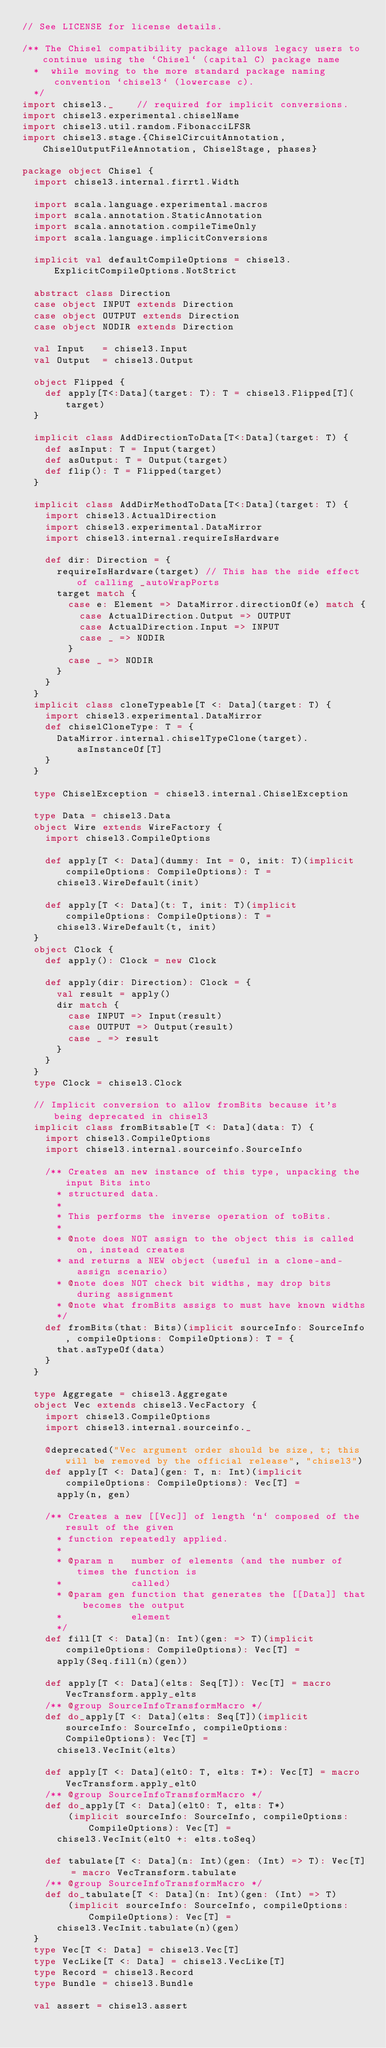<code> <loc_0><loc_0><loc_500><loc_500><_Scala_>// See LICENSE for license details.

/** The Chisel compatibility package allows legacy users to continue using the `Chisel` (capital C) package name
  *  while moving to the more standard package naming convention `chisel3` (lowercase c).
  */
import chisel3._    // required for implicit conversions.
import chisel3.experimental.chiselName
import chisel3.util.random.FibonacciLFSR
import chisel3.stage.{ChiselCircuitAnnotation, ChiselOutputFileAnnotation, ChiselStage, phases}

package object Chisel {
  import chisel3.internal.firrtl.Width

  import scala.language.experimental.macros
  import scala.annotation.StaticAnnotation
  import scala.annotation.compileTimeOnly
  import scala.language.implicitConversions

  implicit val defaultCompileOptions = chisel3.ExplicitCompileOptions.NotStrict

  abstract class Direction
  case object INPUT extends Direction
  case object OUTPUT extends Direction
  case object NODIR extends Direction

  val Input   = chisel3.Input
  val Output  = chisel3.Output

  object Flipped {
    def apply[T<:Data](target: T): T = chisel3.Flipped[T](target)
  }

  implicit class AddDirectionToData[T<:Data](target: T) {
    def asInput: T = Input(target)
    def asOutput: T = Output(target)
    def flip(): T = Flipped(target)
  }

  implicit class AddDirMethodToData[T<:Data](target: T) {
    import chisel3.ActualDirection
    import chisel3.experimental.DataMirror
    import chisel3.internal.requireIsHardware

    def dir: Direction = {
      requireIsHardware(target) // This has the side effect of calling _autoWrapPorts
      target match {
        case e: Element => DataMirror.directionOf(e) match {
          case ActualDirection.Output => OUTPUT
          case ActualDirection.Input => INPUT
          case _ => NODIR
        }
        case _ => NODIR
      }
    }
  }
  implicit class cloneTypeable[T <: Data](target: T) {
    import chisel3.experimental.DataMirror
    def chiselCloneType: T = {
      DataMirror.internal.chiselTypeClone(target).asInstanceOf[T]
    }
  }

  type ChiselException = chisel3.internal.ChiselException

  type Data = chisel3.Data
  object Wire extends WireFactory {
    import chisel3.CompileOptions

    def apply[T <: Data](dummy: Int = 0, init: T)(implicit compileOptions: CompileOptions): T =
      chisel3.WireDefault(init)

    def apply[T <: Data](t: T, init: T)(implicit compileOptions: CompileOptions): T =
      chisel3.WireDefault(t, init)
  }
  object Clock {
    def apply(): Clock = new Clock

    def apply(dir: Direction): Clock = {
      val result = apply()
      dir match {
        case INPUT => Input(result)
        case OUTPUT => Output(result)
        case _ => result
      }
    }
  }
  type Clock = chisel3.Clock

  // Implicit conversion to allow fromBits because it's being deprecated in chisel3
  implicit class fromBitsable[T <: Data](data: T) {
    import chisel3.CompileOptions
    import chisel3.internal.sourceinfo.SourceInfo

    /** Creates an new instance of this type, unpacking the input Bits into
      * structured data.
      *
      * This performs the inverse operation of toBits.
      *
      * @note does NOT assign to the object this is called on, instead creates
      * and returns a NEW object (useful in a clone-and-assign scenario)
      * @note does NOT check bit widths, may drop bits during assignment
      * @note what fromBits assigs to must have known widths
      */
    def fromBits(that: Bits)(implicit sourceInfo: SourceInfo, compileOptions: CompileOptions): T = {
      that.asTypeOf(data)
    }
  }

  type Aggregate = chisel3.Aggregate
  object Vec extends chisel3.VecFactory {
    import chisel3.CompileOptions
    import chisel3.internal.sourceinfo._

    @deprecated("Vec argument order should be size, t; this will be removed by the official release", "chisel3")
    def apply[T <: Data](gen: T, n: Int)(implicit compileOptions: CompileOptions): Vec[T] =
      apply(n, gen)

    /** Creates a new [[Vec]] of length `n` composed of the result of the given
      * function repeatedly applied.
      *
      * @param n   number of elements (and the number of times the function is
      *            called)
      * @param gen function that generates the [[Data]] that becomes the output
      *            element
      */
    def fill[T <: Data](n: Int)(gen: => T)(implicit compileOptions: CompileOptions): Vec[T] =
      apply(Seq.fill(n)(gen))

    def apply[T <: Data](elts: Seq[T]): Vec[T] = macro VecTransform.apply_elts
    /** @group SourceInfoTransformMacro */
    def do_apply[T <: Data](elts: Seq[T])(implicit sourceInfo: SourceInfo, compileOptions: CompileOptions): Vec[T] =
      chisel3.VecInit(elts)

    def apply[T <: Data](elt0: T, elts: T*): Vec[T] = macro VecTransform.apply_elt0
    /** @group SourceInfoTransformMacro */
    def do_apply[T <: Data](elt0: T, elts: T*)
        (implicit sourceInfo: SourceInfo, compileOptions: CompileOptions): Vec[T] =
      chisel3.VecInit(elt0 +: elts.toSeq)

    def tabulate[T <: Data](n: Int)(gen: (Int) => T): Vec[T] = macro VecTransform.tabulate
    /** @group SourceInfoTransformMacro */
    def do_tabulate[T <: Data](n: Int)(gen: (Int) => T)
        (implicit sourceInfo: SourceInfo, compileOptions: CompileOptions): Vec[T] =
      chisel3.VecInit.tabulate(n)(gen)
  }
  type Vec[T <: Data] = chisel3.Vec[T]
  type VecLike[T <: Data] = chisel3.VecLike[T]
  type Record = chisel3.Record
  type Bundle = chisel3.Bundle

  val assert = chisel3.assert</code> 